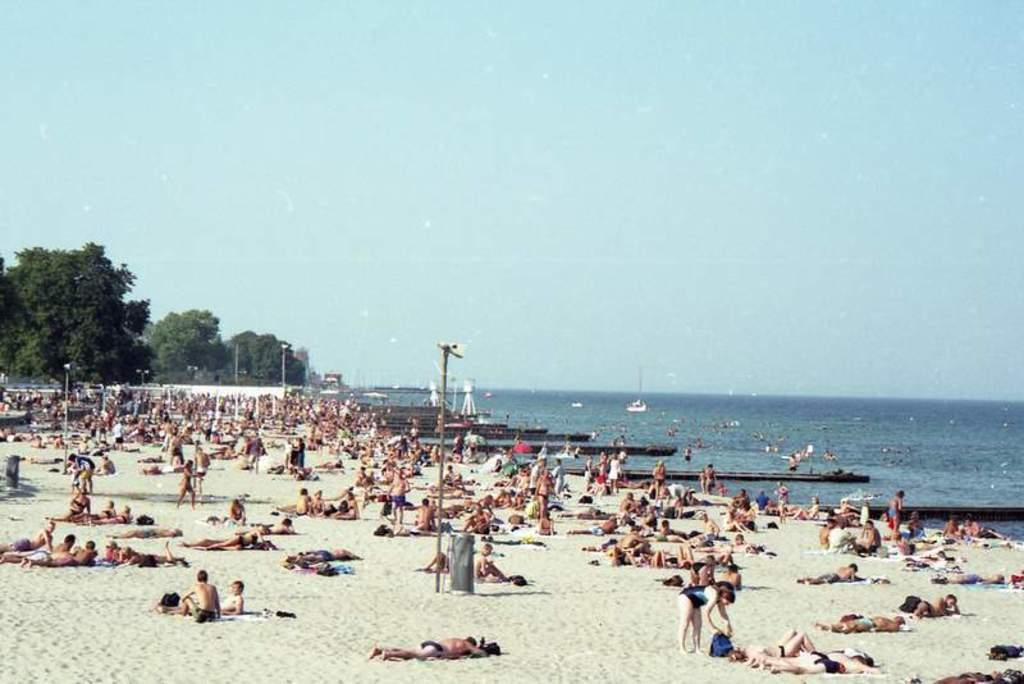How many people are in the image? There are people in the image, but the exact number is not specified. What type of terrain is visible in the image? There is sand in the image, which suggests a beach or desert setting. What object can be seen standing upright in the image? There is a pole in the image. What natural elements can be seen in the background of the image? There is water, trees, and the sky visible in the background of the image. Can you tell me how many pets are present in the image? There is no mention of pets in the image, so it cannot be determined from the picture. What type of duck can be seen swimming in the water in the image? There is no duck present in the image, so it cannot be determined from the picture. 